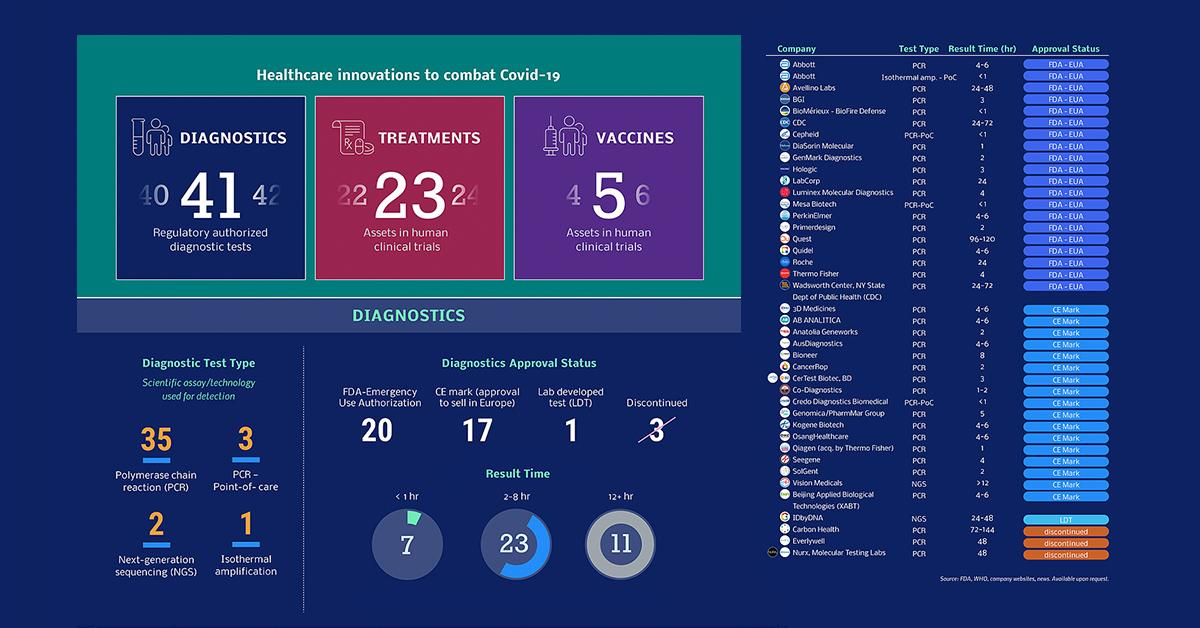Draw attention to some important aspects in this diagram. There is one lab-developed test. To date, 23 treatments have been developed. To date, approximately five vaccines have been developed. The majority of diagnostic tests take 2 to 8 hours. Out of the 41 diagnostic tests evaluated, the majority, 34 tests, fall under the category of Polymerase Chain Reaction (PCR) testing. 